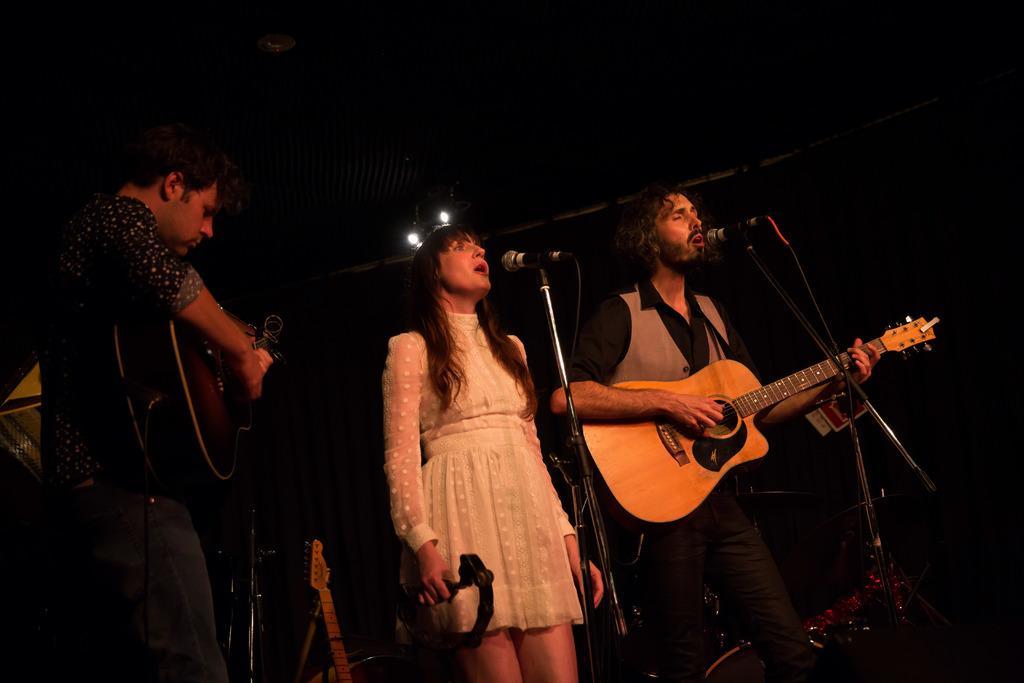Describe this image in one or two sentences. This is the picture taken on a stage, there are group of people holding the guitar and singing a song in front of these people there is a microphone with stand. Background of these people is in black color. 